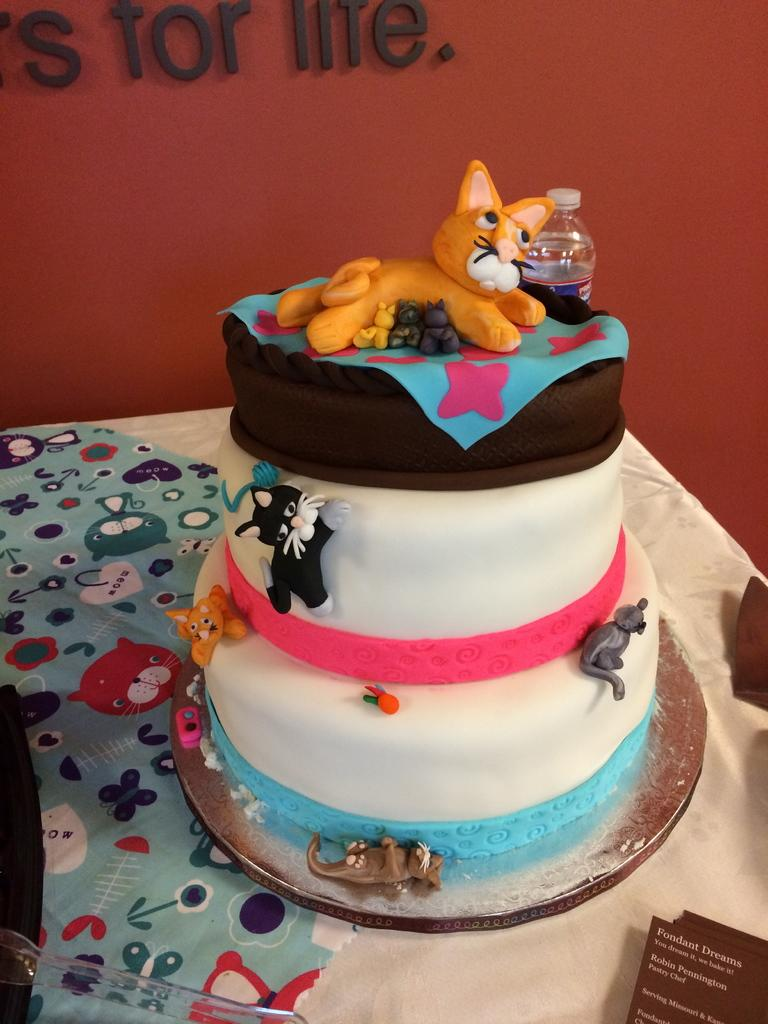What is the main subject of the image? The main subject of the image is a beautiful cake. What type of structures can be seen on the cake? The cake has structures of a cat, a mouse, and a kitten. What type of linen is used to cover the table in the image? There is no table or linen present in the image; it only features a cake with structures of a cat, a mouse, and a kitten. 